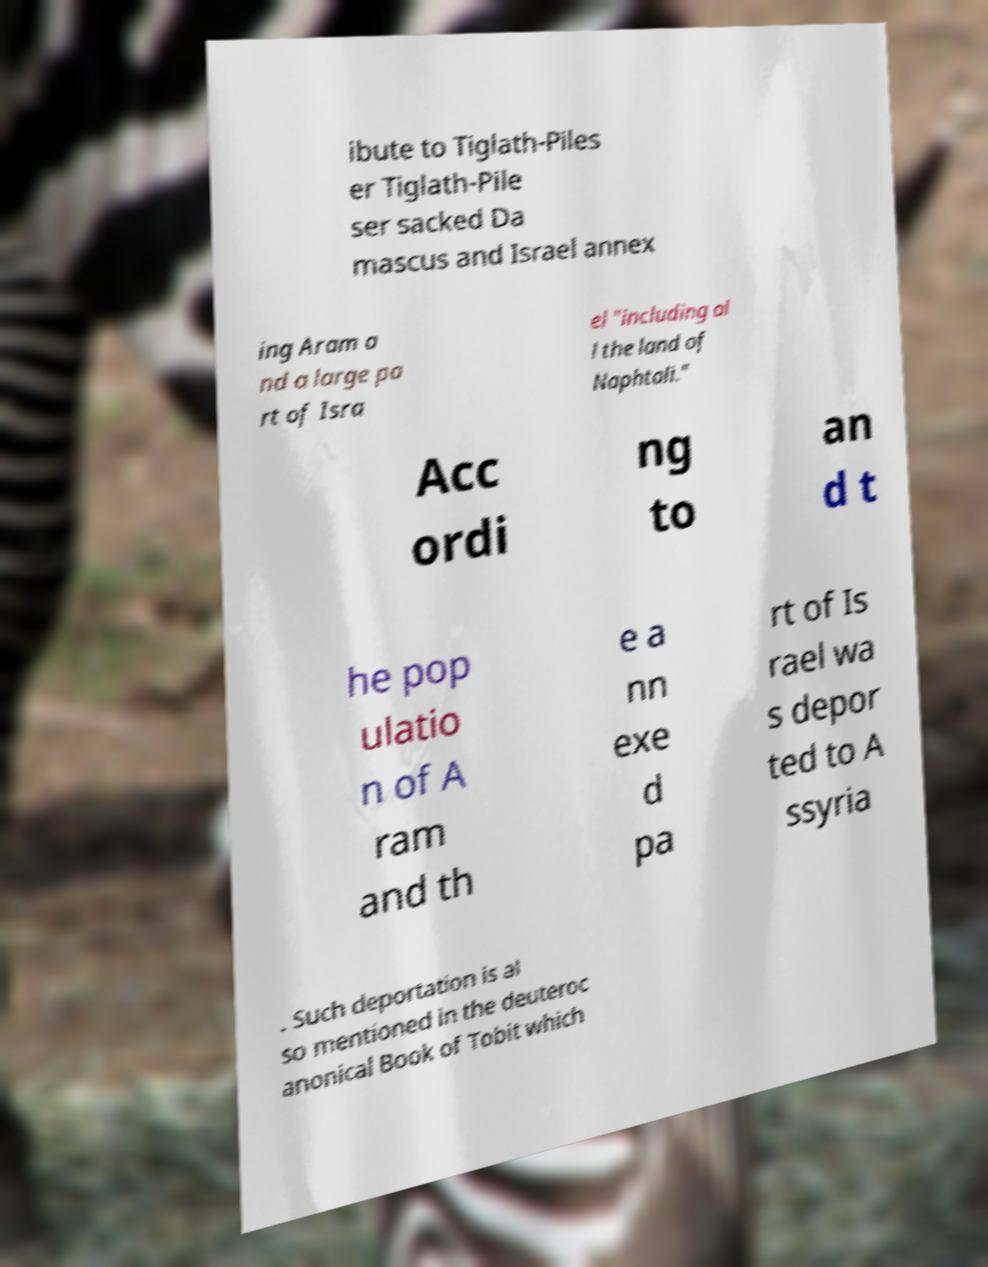Could you assist in decoding the text presented in this image and type it out clearly? ibute to Tiglath-Piles er Tiglath-Pile ser sacked Da mascus and Israel annex ing Aram a nd a large pa rt of Isra el "including al l the land of Naphtali." Acc ordi ng to an d t he pop ulatio n of A ram and th e a nn exe d pa rt of Is rael wa s depor ted to A ssyria . Such deportation is al so mentioned in the deuteroc anonical Book of Tobit which 